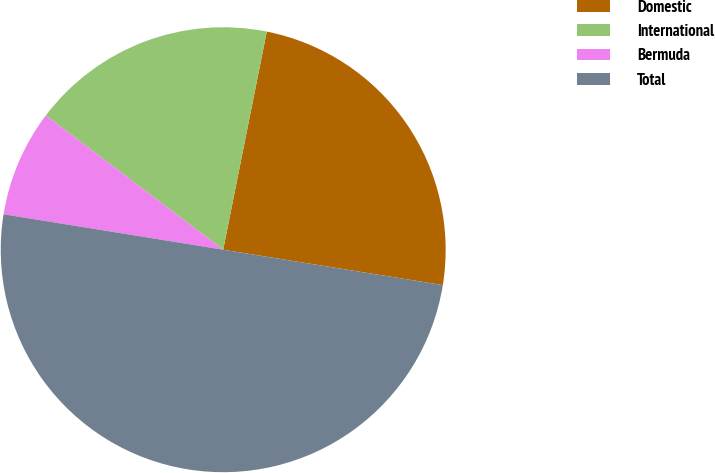Convert chart to OTSL. <chart><loc_0><loc_0><loc_500><loc_500><pie_chart><fcel>Domestic<fcel>International<fcel>Bermuda<fcel>Total<nl><fcel>24.4%<fcel>17.82%<fcel>7.77%<fcel>50.0%<nl></chart> 